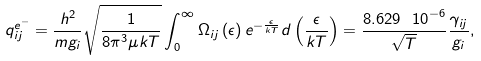Convert formula to latex. <formula><loc_0><loc_0><loc_500><loc_500>q ^ { e ^ { - } } _ { i j } = \frac { h ^ { 2 } } { m g _ { i } } \sqrt { \frac { 1 } { 8 { \pi } ^ { 3 } \mu k T } } \int ^ { \infty } _ { 0 } \Omega _ { i j } \left ( \epsilon \right ) e ^ { - \frac { \epsilon } { k T } } d \left ( \frac { \epsilon } { k T } \right ) = \frac { 8 . 6 2 9 \ { 1 0 } ^ { - 6 } } { \sqrt { T } } \frac { \gamma _ { i j } } { g _ { i } } ,</formula> 